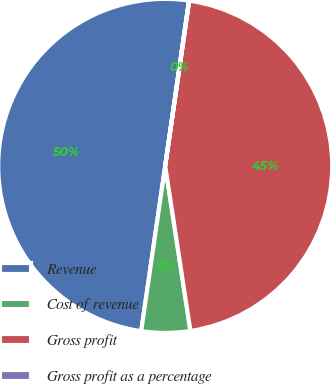<chart> <loc_0><loc_0><loc_500><loc_500><pie_chart><fcel>Revenue<fcel>Cost of revenue<fcel>Gross profit<fcel>Gross profit as a percentage<nl><fcel>49.98%<fcel>4.71%<fcel>45.29%<fcel>0.02%<nl></chart> 